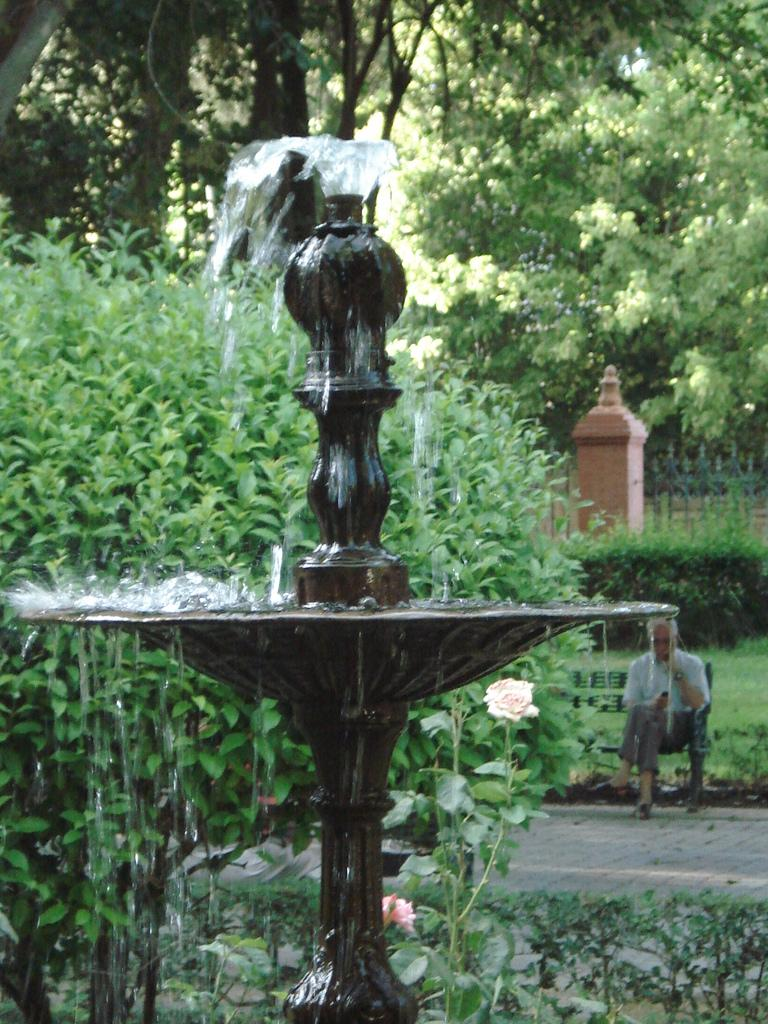What is the main feature in the image? There is a fountain in the image. What can be seen in the background of the image? There are plants, trees, a pillar, a fence, grass, and a floor in the background of the image. Is there any indication of human presence in the image? Yes, there is a person sitting on a bench in the background of the image. Can you tell me how many wrist cords are visible in the image? There are no wrist cords present in the image. What type of existence does the fountain have in the image? The fountain is a physical object in the image, not an abstract concept or idea. 